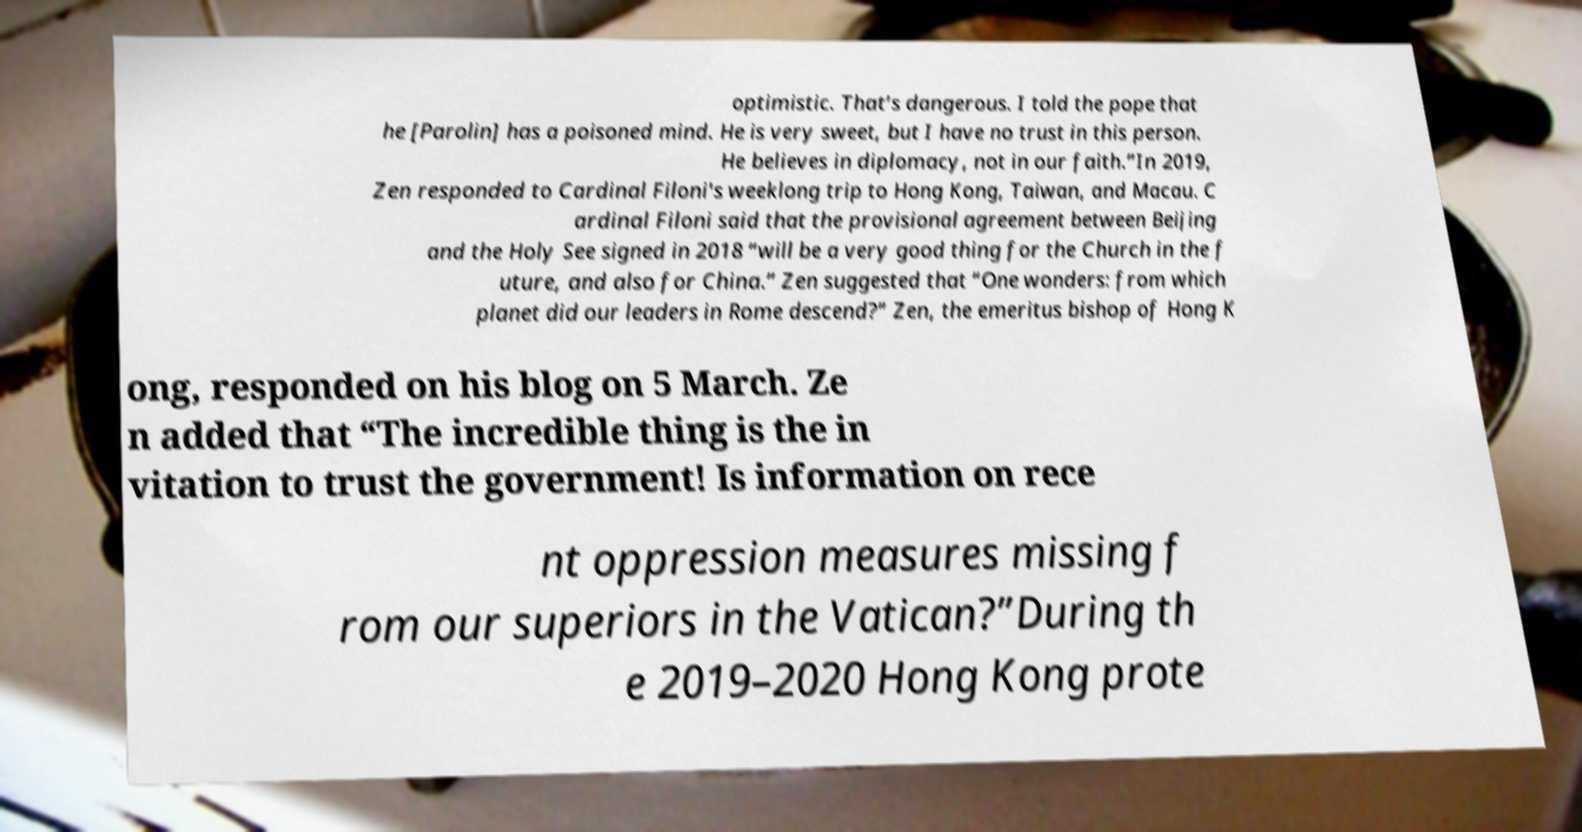Please read and relay the text visible in this image. What does it say? optimistic. That’s dangerous. I told the pope that he [Parolin] has a poisoned mind. He is very sweet, but I have no trust in this person. He believes in diplomacy, not in our faith.”In 2019, Zen responded to Cardinal Filoni's weeklong trip to Hong Kong, Taiwan, and Macau. C ardinal Filoni said that the provisional agreement between Beijing and the Holy See signed in 2018 “will be a very good thing for the Church in the f uture, and also for China.” Zen suggested that “One wonders: from which planet did our leaders in Rome descend?” Zen, the emeritus bishop of Hong K ong, responded on his blog on 5 March. Ze n added that “The incredible thing is the in vitation to trust the government! Is information on rece nt oppression measures missing f rom our superiors in the Vatican?”During th e 2019–2020 Hong Kong prote 